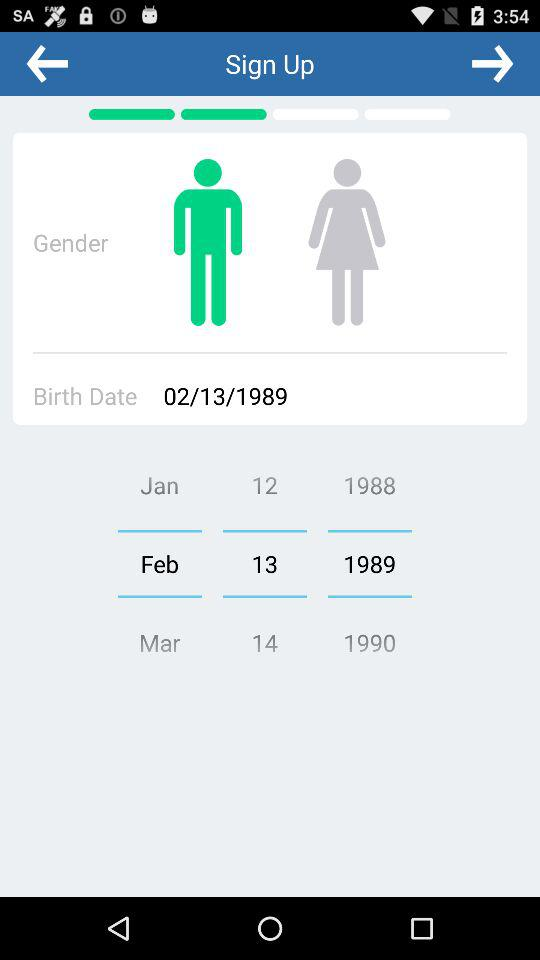Which gender is selected? The selected gender is male. 